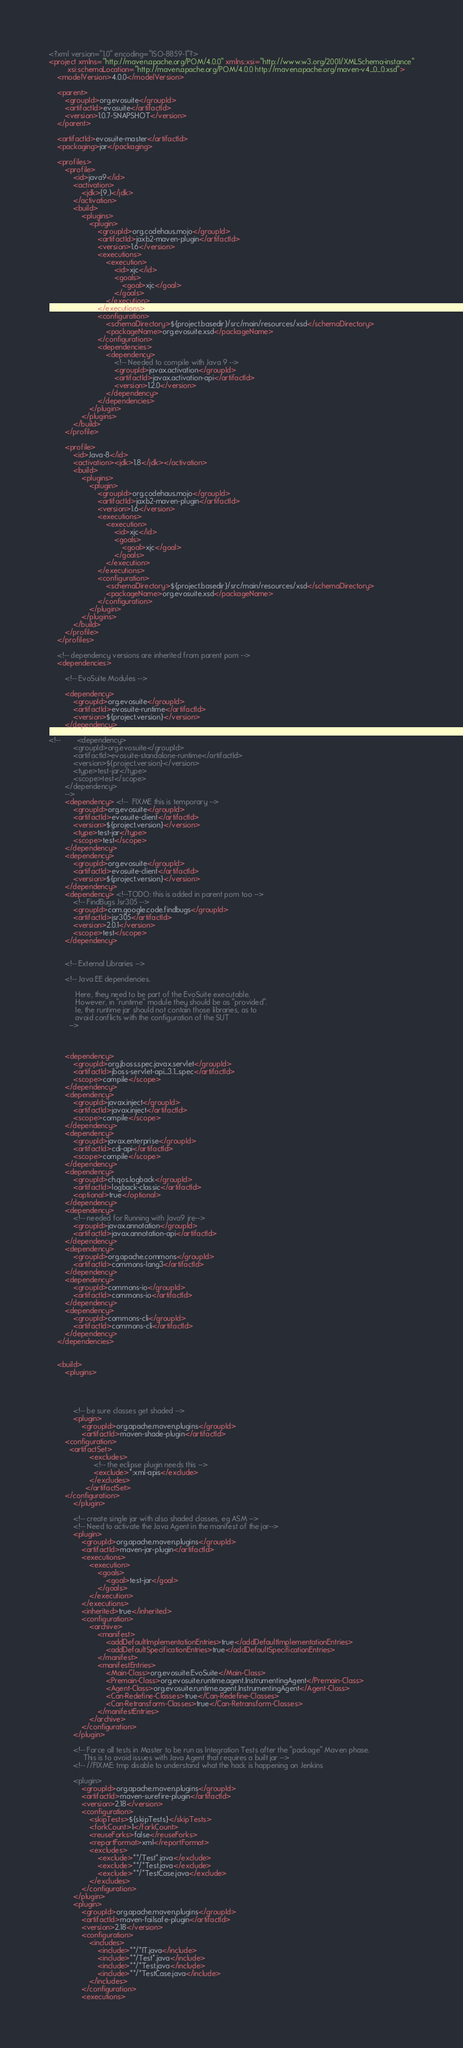Convert code to text. <code><loc_0><loc_0><loc_500><loc_500><_XML_><?xml version="1.0" encoding="ISO-8859-1"?>
<project xmlns="http://maven.apache.org/POM/4.0.0" xmlns:xsi="http://www.w3.org/2001/XMLSchema-instance"
         xsi:schemaLocation="http://maven.apache.org/POM/4.0.0 http://maven.apache.org/maven-v4_0_0.xsd">
    <modelVersion>4.0.0</modelVersion>

    <parent>
        <groupId>org.evosuite</groupId>
        <artifactId>evosuite</artifactId>
        <version>1.0.7-SNAPSHOT</version>
    </parent>

    <artifactId>evosuite-master</artifactId>
    <packaging>jar</packaging>

    <profiles>
        <profile>
            <id>java9</id>
            <activation>
                <jdk>[9,)</jdk>
            </activation>
            <build>
                <plugins>
                    <plugin>
                        <groupId>org.codehaus.mojo</groupId>
                        <artifactId>jaxb2-maven-plugin</artifactId>
                        <version>1.6</version>
                        <executions>
                            <execution>
                                <id>xjc</id>
                                <goals>
                                    <goal>xjc</goal>
                                </goals>
                            </execution>
                        </executions>
                        <configuration>
                            <schemaDirectory>${project.basedir}/src/main/resources/xsd</schemaDirectory>
                            <packageName>org.evosuite.xsd</packageName>
                        </configuration>
                        <dependencies>
                            <dependency>
                                <!-- Needed to compile with Java 9 -->
                                <groupId>javax.activation</groupId>
                                <artifactId>javax.activation-api</artifactId>
                                <version>1.2.0</version>
                            </dependency>
                        </dependencies>
                    </plugin>
                </plugins>
            </build>
        </profile>

        <profile>
            <id>Java-8</id>
            <activation><jdk>1.8</jdk></activation>
            <build>
                <plugins>
                    <plugin>
                        <groupId>org.codehaus.mojo</groupId>
                        <artifactId>jaxb2-maven-plugin</artifactId>
                        <version>1.6</version>
                        <executions>
                            <execution>
                                <id>xjc</id>
                                <goals>
                                    <goal>xjc</goal>
                                </goals>
                            </execution>
                        </executions>
                        <configuration>
                            <schemaDirectory>${project.basedir}/src/main/resources/xsd</schemaDirectory>
                            <packageName>org.evosuite.xsd</packageName>
                        </configuration>
                    </plugin>
                </plugins>
            </build>
        </profile>
    </profiles>

    <!-- dependency versions are inherited from parent pom -->
    <dependencies>

        <!-- EvoSuite Modules -->

        <dependency>
            <groupId>org.evosuite</groupId>
            <artifactId>evosuite-runtime</artifactId>
            <version>${project.version}</version>
        </dependency>

<!--        <dependency>
            <groupId>org.evosuite</groupId>
            <artifactId>evosuite-standalone-runtime</artifactId>
            <version>${project.version}</version>
            <type>test-jar</type>
            <scope>test</scope>
        </dependency>
        -->
        <dependency> <!--  FIXME this is temporary -->
            <groupId>org.evosuite</groupId>
            <artifactId>evosuite-client</artifactId>
            <version>${project.version}</version>
            <type>test-jar</type>
            <scope>test</scope>
        </dependency>
        <dependency>
            <groupId>org.evosuite</groupId>
            <artifactId>evosuite-client</artifactId>
            <version>${project.version}</version>
        </dependency>
        <dependency> <!--TODO: this is added in parent pom too -->
            <!-- FindBugs Jsr305 -->
            <groupId>com.google.code.findbugs</groupId>
            <artifactId>jsr305</artifactId>
            <version>2.0.1</version>
            <scope>test</scope>
        </dependency>


        <!-- External Libraries -->

        <!-- Java EE dependencies.

             Here, they need to be part of the EvoSuite executable.
             However, in "runtime" module they should be as "provided".
             Ie, the runtime jar should not contain those libraries, as to
             avoid conflicts with the configuration of the SUT
          -->



        <dependency>
            <groupId>org.jboss.spec.javax.servlet</groupId>
            <artifactId>jboss-servlet-api_3.1_spec</artifactId>
            <scope>compile</scope>
        </dependency>
        <dependency>
            <groupId>javax.inject</groupId>
            <artifactId>javax.inject</artifactId>
            <scope>compile</scope>
        </dependency>
        <dependency>
            <groupId>javax.enterprise</groupId>
            <artifactId>cdi-api</artifactId>
            <scope>compile</scope>
        </dependency>
        <dependency>
            <groupId>ch.qos.logback</groupId>
            <artifactId>logback-classic</artifactId>
            <optional>true</optional>
        </dependency>
        <dependency>
            <!-- needed for Running with Java9 jre-->
            <groupId>javax.annotation</groupId>
            <artifactId>javax.annotation-api</artifactId>
        </dependency>
        <dependency>
            <groupId>org.apache.commons</groupId>
            <artifactId>commons-lang3</artifactId>
        </dependency>
        <dependency>
            <groupId>commons-io</groupId>
            <artifactId>commons-io</artifactId>
        </dependency>
        <dependency>
            <groupId>commons-cli</groupId>
            <artifactId>commons-cli</artifactId>
        </dependency>
    </dependencies>


    <build>
        <plugins>




            <!-- be sure classes get shaded -->
            <plugin>
                <groupId>org.apache.maven.plugins</groupId>
                <artifactId>maven-shade-plugin</artifactId>
		<configuration>
		  <artifactSet>
                    <excludes>
                      <!-- the eclipse plugin needs this -->
                      <exclude>*:xml-apis</exclude>
                    </excludes>
                  </artifactSet>
		</configuration>
            </plugin>

            <!-- create single jar with also shaded classes, eg ASM -->
            <!-- Need to activate the Java Agent in the manifest of the jar-->
            <plugin>
                <groupId>org.apache.maven.plugins</groupId>
                <artifactId>maven-jar-plugin</artifactId>
                <executions>
                    <execution>
                        <goals>
                            <goal>test-jar</goal>
                        </goals>
                    </execution>
                </executions>
                <inherited>true</inherited>
                <configuration>
                    <archive>
                        <manifest>
                            <addDefaultImplementationEntries>true</addDefaultImplementationEntries>
                            <addDefaultSpecificationEntries>true</addDefaultSpecificationEntries>
                        </manifest>
                        <manifestEntries>
                            <Main-Class>org.evosuite.EvoSuite</Main-Class>
                            <Premain-Class>org.evosuite.runtime.agent.InstrumentingAgent</Premain-Class>
                            <Agent-Class>org.evosuite.runtime.agent.InstrumentingAgent</Agent-Class>
                            <Can-Redefine-Classes>true</Can-Redefine-Classes>
                            <Can-Retransform-Classes>true</Can-Retransform-Classes>
                        </manifestEntries>
                    </archive>
                </configuration>
            </plugin>

            <!-- Force all tests in Master to be run as Integration Tests after the "package" Maven phase.
                 This is to avoid issues with Java Agent that requires a built jar -->
            <!-- //FIXME: tmp disable to understand what the hack is happening on Jenkins

            <plugin>
                <groupId>org.apache.maven.plugins</groupId>
                <artifactId>maven-surefire-plugin</artifactId>
                <version>2.18</version>
                <configuration>
                    <skipTests>${skipTests}</skipTests>
                    <forkCount>1</forkCount>
                    <reuseForks>false</reuseForks>
                    <reportFormat>xml</reportFormat>
                    <excludes>
                        <exclude>**/Test*.java</exclude>
                        <exclude>**/*Test.java</exclude>
                        <exclude>**/*TestCase.java</exclude>
                    </excludes>
                </configuration>
            </plugin>
            <plugin>
                <groupId>org.apache.maven.plugins</groupId>
                <artifactId>maven-failsafe-plugin</artifactId>
                <version>2.18</version>
                <configuration>
                    <includes>
                        <include>**/*IT.java</include>
                        <include>**/Test*.java</include>
                        <include>**/*Test.java</include>
                        <include>**/*TestCase.java</include>
                    </includes>
                </configuration>
                <executions></code> 